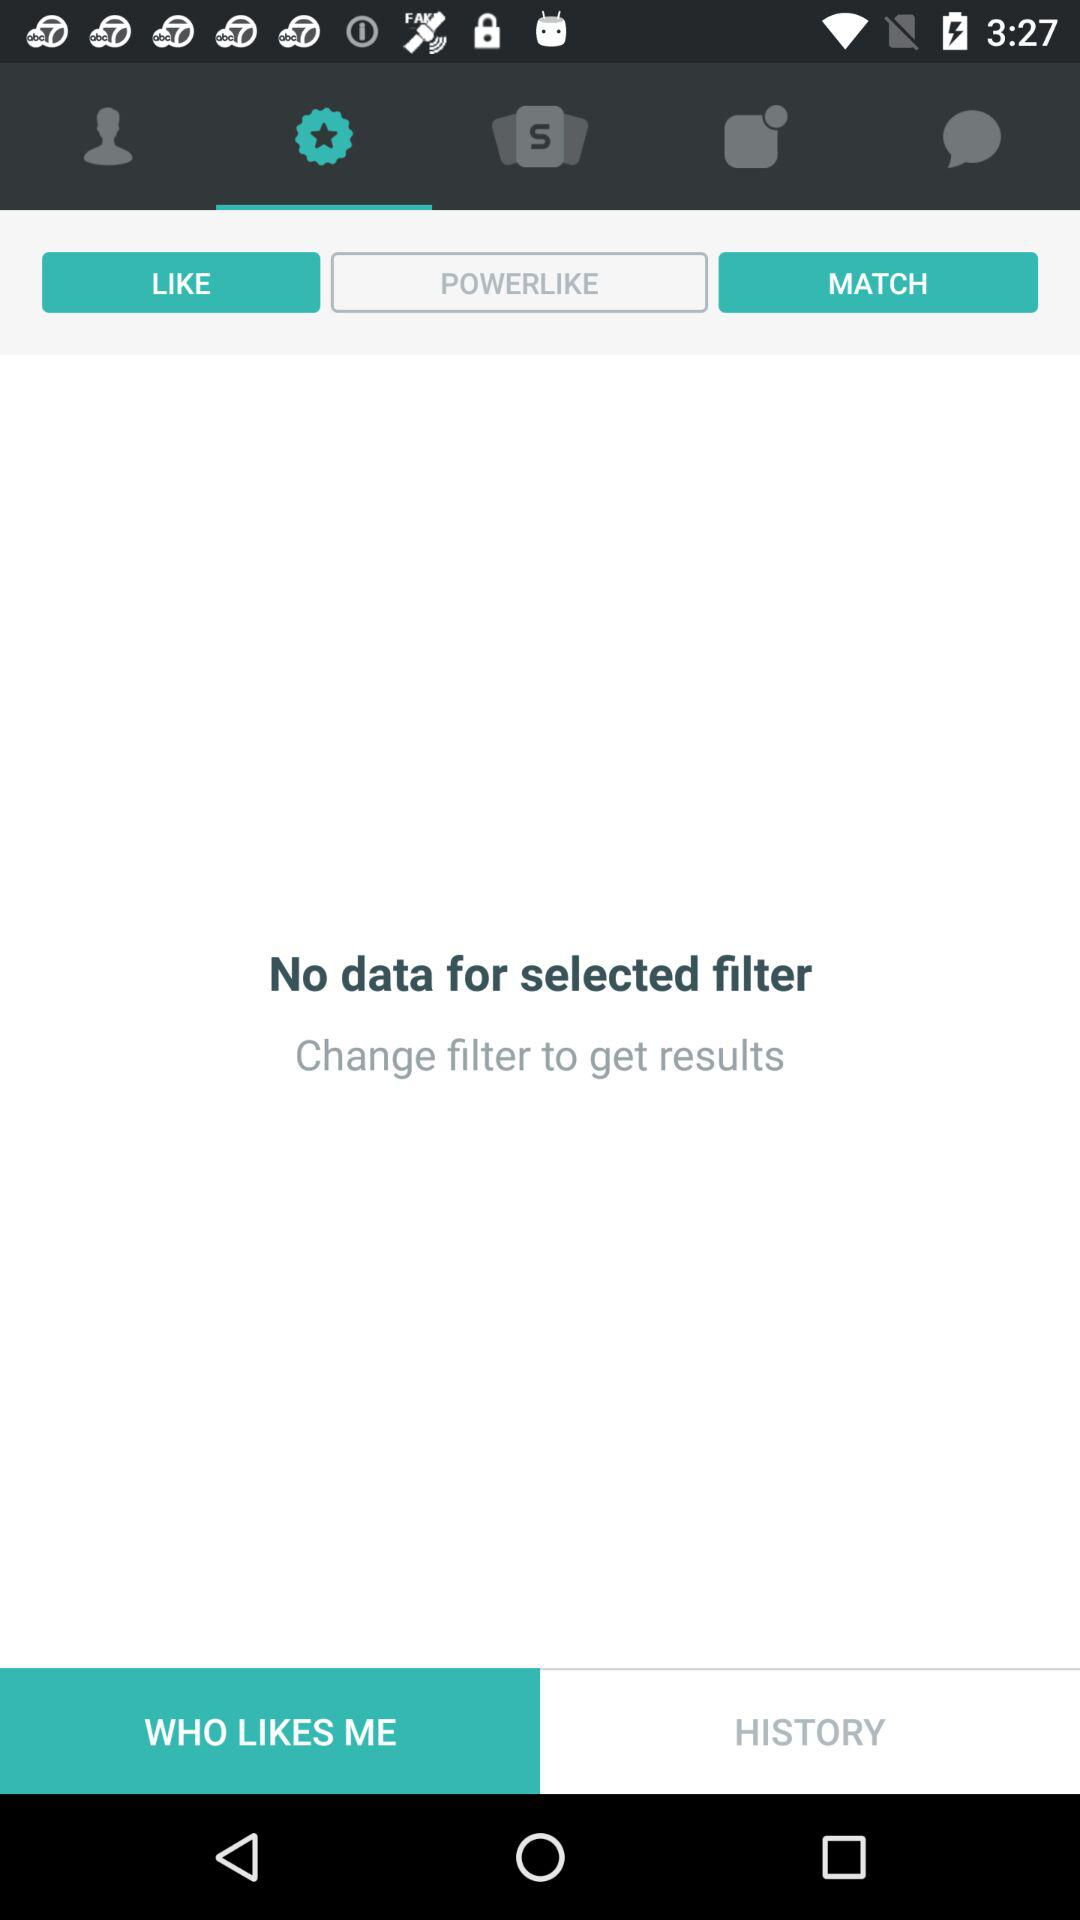What tab is currently selected at the bottom bar? The selected tab is "Who Likes Me". 